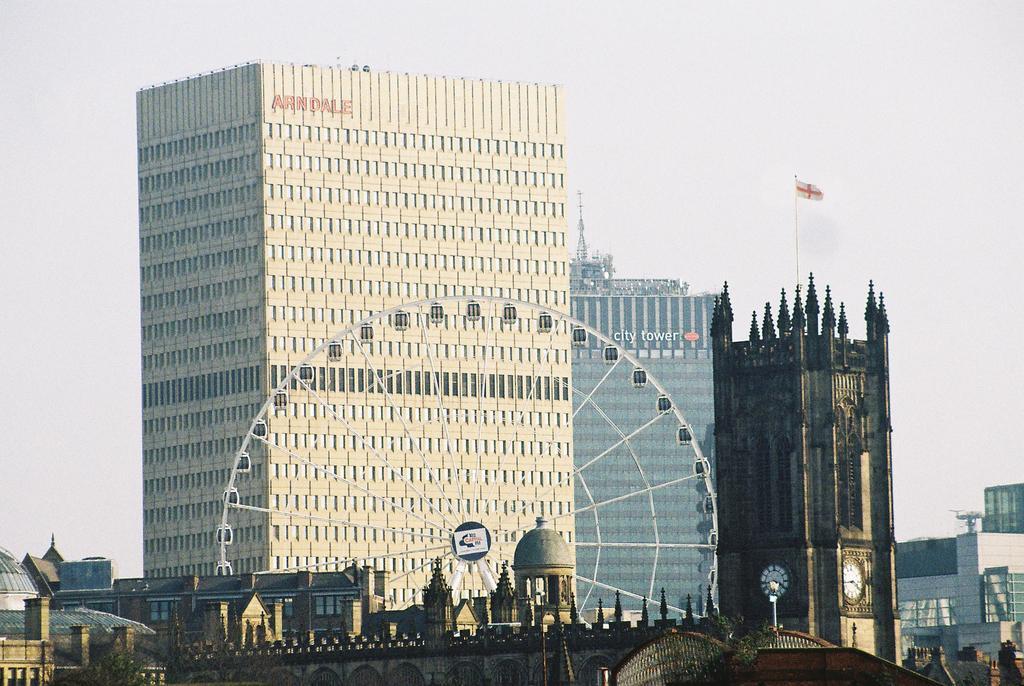How would you summarize this image in a sentence or two? In this image there are many buildings. This is a giant wheel. This is looking like a bridge. This is a clock tower. On top of it there is a flag. The sky is clear. 